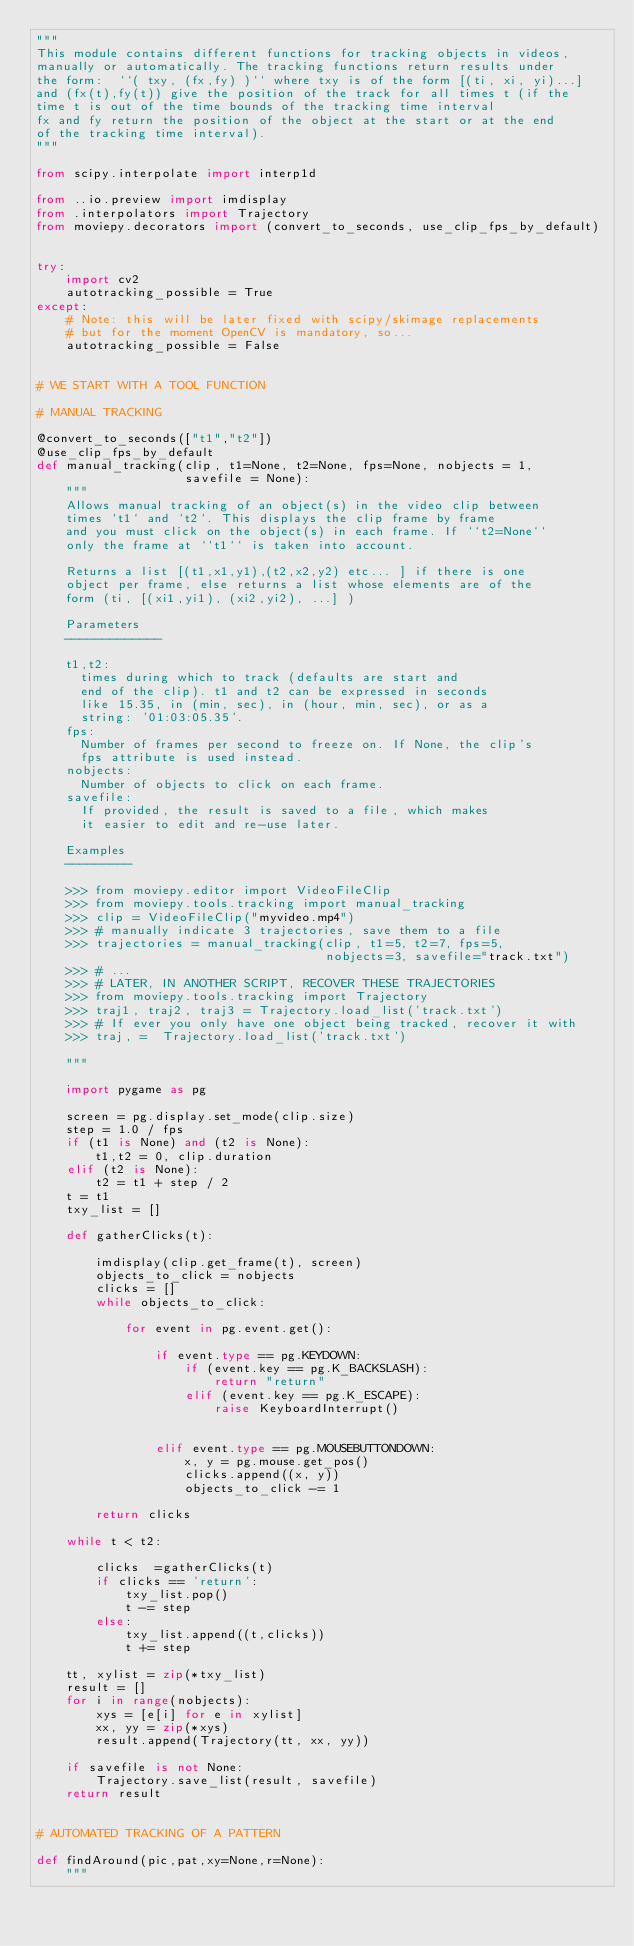<code> <loc_0><loc_0><loc_500><loc_500><_Python_>"""
This module contains different functions for tracking objects in videos,
manually or automatically. The tracking functions return results under
the form:  ``( txy, (fx,fy) )`` where txy is of the form [(ti, xi, yi)...]
and (fx(t),fy(t)) give the position of the track for all times t (if the
time t is out of the time bounds of the tracking time interval
fx and fy return the position of the object at the start or at the end
of the tracking time interval).
"""

from scipy.interpolate import interp1d

from ..io.preview import imdisplay
from .interpolators import Trajectory
from moviepy.decorators import (convert_to_seconds, use_clip_fps_by_default)


try:
    import cv2
    autotracking_possible = True
except:
    # Note: this will be later fixed with scipy/skimage replacements
    # but for the moment OpenCV is mandatory, so...
    autotracking_possible = False


# WE START WITH A TOOL FUNCTION

# MANUAL TRACKING

@convert_to_seconds(["t1","t2"])
@use_clip_fps_by_default
def manual_tracking(clip, t1=None, t2=None, fps=None, nobjects = 1,
                    savefile = None):
    """
    Allows manual tracking of an object(s) in the video clip between
    times `t1` and `t2`. This displays the clip frame by frame
    and you must click on the object(s) in each frame. If ``t2=None``
    only the frame at ``t1`` is taken into account.
    
    Returns a list [(t1,x1,y1),(t2,x2,y2) etc... ] if there is one
    object per frame, else returns a list whose elements are of the 
    form (ti, [(xi1,yi1), (xi2,yi2), ...] )
    
    Parameters
    -------------

    t1,t2:
      times during which to track (defaults are start and
      end of the clip). t1 and t2 can be expressed in seconds
      like 15.35, in (min, sec), in (hour, min, sec), or as a
      string: '01:03:05.35'.
    fps:
      Number of frames per second to freeze on. If None, the clip's
      fps attribute is used instead.
    nobjects:
      Number of objects to click on each frame.
    savefile:
      If provided, the result is saved to a file, which makes
      it easier to edit and re-use later.

    Examples
    ---------
    
    >>> from moviepy.editor import VideoFileClip
    >>> from moviepy.tools.tracking import manual_tracking
    >>> clip = VideoFileClip("myvideo.mp4")
    >>> # manually indicate 3 trajectories, save them to a file
    >>> trajectories = manual_tracking(clip, t1=5, t2=7, fps=5,
                                       nobjects=3, savefile="track.txt")
    >>> # ...
    >>> # LATER, IN ANOTHER SCRIPT, RECOVER THESE TRAJECTORIES
    >>> from moviepy.tools.tracking import Trajectory
    >>> traj1, traj2, traj3 = Trajectory.load_list('track.txt')
    >>> # If ever you only have one object being tracked, recover it with
    >>> traj, =  Trajectory.load_list('track.txt')
    
    """
    
    import pygame as pg

    screen = pg.display.set_mode(clip.size)
    step = 1.0 / fps
    if (t1 is None) and (t2 is None):
        t1,t2 = 0, clip.duration
    elif (t2 is None):
        t2 = t1 + step / 2
    t = t1
    txy_list = []
    
    def gatherClicks(t):
        
        imdisplay(clip.get_frame(t), screen)
        objects_to_click = nobjects
        clicks = []
        while objects_to_click:

            for event in pg.event.get():

                if event.type == pg.KEYDOWN:
                    if (event.key == pg.K_BACKSLASH):
                        return "return"
                    elif (event.key == pg.K_ESCAPE):
                        raise KeyboardInterrupt()
                        

                elif event.type == pg.MOUSEBUTTONDOWN:
                    x, y = pg.mouse.get_pos()
                    clicks.append((x, y))
                    objects_to_click -= 1
                    
        return clicks
        
    while t < t2:
        
        clicks  =gatherClicks(t)
        if clicks == 'return':
            txy_list.pop()
            t -= step
        else:
            txy_list.append((t,clicks))
            t += step

    tt, xylist = zip(*txy_list) 
    result = []
    for i in range(nobjects):
        xys = [e[i] for e in xylist]
        xx, yy = zip(*xys)
        result.append(Trajectory(tt, xx, yy))
    
    if savefile is not None:
        Trajectory.save_list(result, savefile)
    return result


# AUTOMATED TRACKING OF A PATTERN

def findAround(pic,pat,xy=None,r=None):
    """</code> 